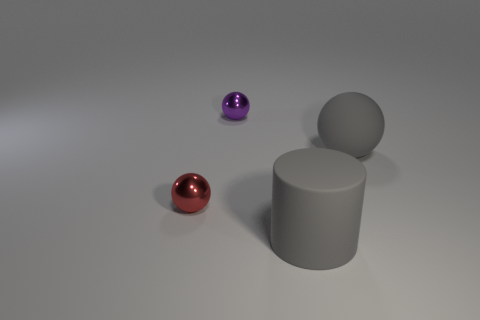What number of red metal objects are right of the rubber object that is in front of the large thing that is behind the red shiny object?
Ensure brevity in your answer.  0. There is a small purple ball; are there any small red balls in front of it?
Give a very brief answer. Yes. What shape is the small purple object?
Your response must be concise. Sphere. There is a large rubber thing that is in front of the tiny red ball that is to the left of the large object that is on the left side of the large rubber sphere; what is its shape?
Keep it short and to the point. Cylinder. What number of other things are there of the same shape as the purple shiny thing?
Provide a succinct answer. 2. The small object in front of the big matte object behind the red metal thing is made of what material?
Your response must be concise. Metal. Is the small purple object made of the same material as the small red sphere behind the cylinder?
Give a very brief answer. Yes. What is the sphere that is both in front of the tiny purple sphere and right of the small red metal thing made of?
Provide a succinct answer. Rubber. What color is the big rubber thing that is behind the small metal thing that is in front of the purple sphere?
Provide a succinct answer. Gray. There is a ball that is on the right side of the purple metallic thing; what material is it?
Your response must be concise. Rubber. 